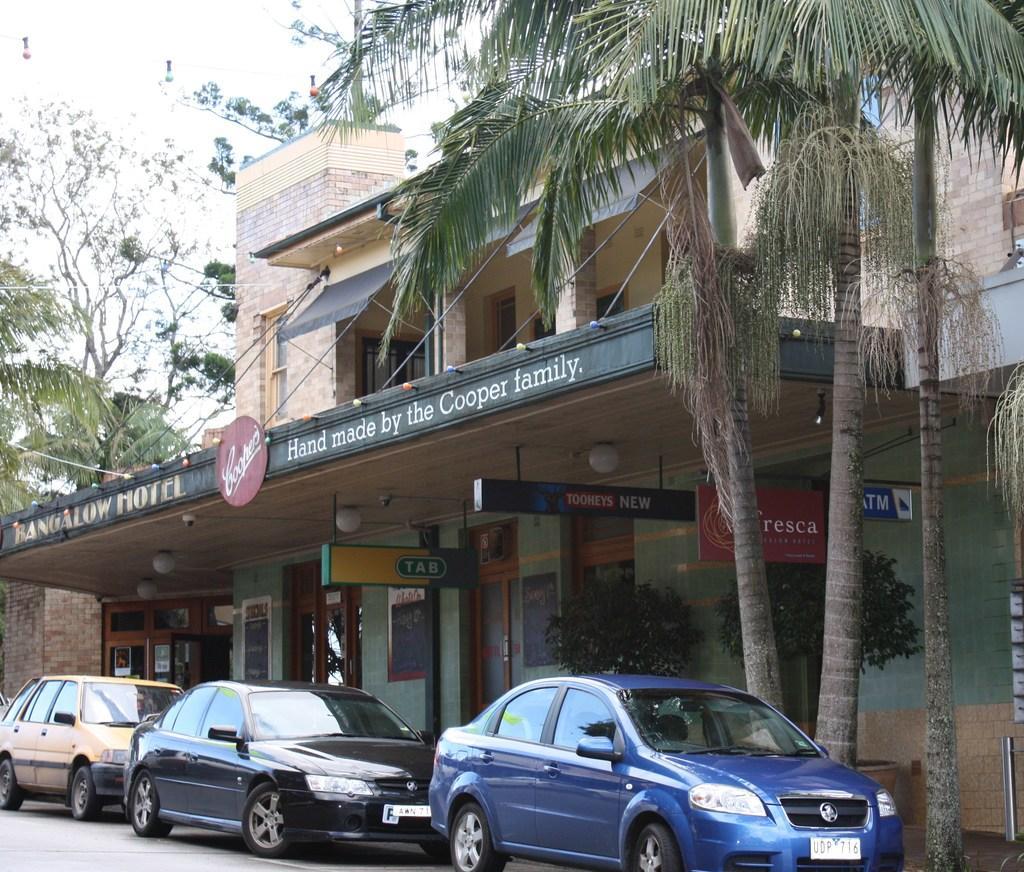How would you summarize this image in a sentence or two? In this picture I can see buildings and trees and few cars parked and i can see boards with text and a cloudy Sky. 